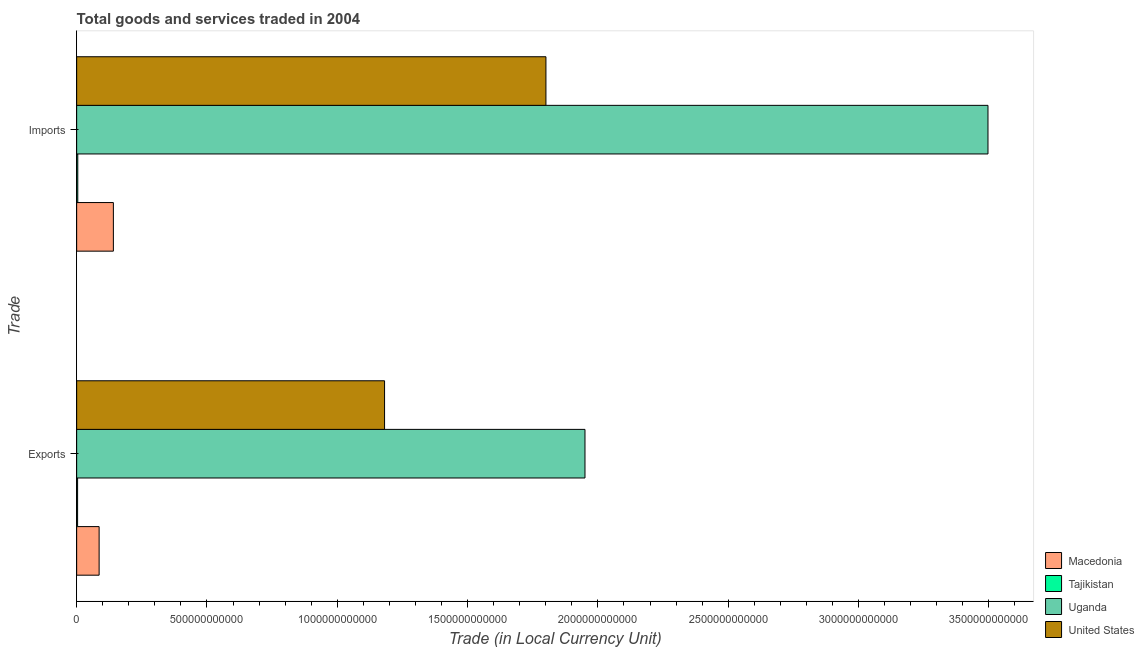How many different coloured bars are there?
Provide a short and direct response. 4. How many groups of bars are there?
Keep it short and to the point. 2. Are the number of bars per tick equal to the number of legend labels?
Provide a short and direct response. Yes. Are the number of bars on each tick of the Y-axis equal?
Provide a succinct answer. Yes. How many bars are there on the 1st tick from the top?
Your answer should be very brief. 4. How many bars are there on the 2nd tick from the bottom?
Give a very brief answer. 4. What is the label of the 2nd group of bars from the top?
Provide a succinct answer. Exports. What is the imports of goods and services in United States?
Offer a very short reply. 1.80e+12. Across all countries, what is the maximum export of goods and services?
Offer a terse response. 1.95e+12. Across all countries, what is the minimum imports of goods and services?
Offer a terse response. 4.31e+09. In which country was the export of goods and services maximum?
Make the answer very short. Uganda. In which country was the imports of goods and services minimum?
Keep it short and to the point. Tajikistan. What is the total imports of goods and services in the graph?
Make the answer very short. 5.44e+12. What is the difference between the imports of goods and services in United States and that in Uganda?
Provide a short and direct response. -1.70e+12. What is the difference between the imports of goods and services in United States and the export of goods and services in Macedonia?
Make the answer very short. 1.71e+12. What is the average export of goods and services per country?
Your response must be concise. 8.05e+11. What is the difference between the imports of goods and services and export of goods and services in Uganda?
Keep it short and to the point. 1.55e+12. In how many countries, is the imports of goods and services greater than 2200000000000 LCU?
Offer a very short reply. 1. What is the ratio of the imports of goods and services in Uganda to that in Tajikistan?
Offer a very short reply. 811.1. In how many countries, is the imports of goods and services greater than the average imports of goods and services taken over all countries?
Give a very brief answer. 2. What does the 4th bar from the top in Exports represents?
Provide a succinct answer. Macedonia. What does the 2nd bar from the bottom in Exports represents?
Give a very brief answer. Tajikistan. What is the difference between two consecutive major ticks on the X-axis?
Offer a very short reply. 5.00e+11. Where does the legend appear in the graph?
Make the answer very short. Bottom right. How are the legend labels stacked?
Provide a succinct answer. Vertical. What is the title of the graph?
Offer a terse response. Total goods and services traded in 2004. What is the label or title of the X-axis?
Give a very brief answer. Trade (in Local Currency Unit). What is the label or title of the Y-axis?
Give a very brief answer. Trade. What is the Trade (in Local Currency Unit) of Macedonia in Exports?
Give a very brief answer. 8.62e+1. What is the Trade (in Local Currency Unit) in Tajikistan in Exports?
Offer a very short reply. 3.60e+09. What is the Trade (in Local Currency Unit) of Uganda in Exports?
Offer a terse response. 1.95e+12. What is the Trade (in Local Currency Unit) in United States in Exports?
Provide a succinct answer. 1.18e+12. What is the Trade (in Local Currency Unit) in Macedonia in Imports?
Provide a succinct answer. 1.41e+11. What is the Trade (in Local Currency Unit) of Tajikistan in Imports?
Offer a very short reply. 4.31e+09. What is the Trade (in Local Currency Unit) in Uganda in Imports?
Your answer should be very brief. 3.50e+12. What is the Trade (in Local Currency Unit) in United States in Imports?
Offer a terse response. 1.80e+12. Across all Trade, what is the maximum Trade (in Local Currency Unit) in Macedonia?
Your response must be concise. 1.41e+11. Across all Trade, what is the maximum Trade (in Local Currency Unit) of Tajikistan?
Your answer should be very brief. 4.31e+09. Across all Trade, what is the maximum Trade (in Local Currency Unit) in Uganda?
Keep it short and to the point. 3.50e+12. Across all Trade, what is the maximum Trade (in Local Currency Unit) of United States?
Provide a short and direct response. 1.80e+12. Across all Trade, what is the minimum Trade (in Local Currency Unit) in Macedonia?
Give a very brief answer. 8.62e+1. Across all Trade, what is the minimum Trade (in Local Currency Unit) of Tajikistan?
Ensure brevity in your answer.  3.60e+09. Across all Trade, what is the minimum Trade (in Local Currency Unit) in Uganda?
Make the answer very short. 1.95e+12. Across all Trade, what is the minimum Trade (in Local Currency Unit) in United States?
Your response must be concise. 1.18e+12. What is the total Trade (in Local Currency Unit) in Macedonia in the graph?
Keep it short and to the point. 2.27e+11. What is the total Trade (in Local Currency Unit) of Tajikistan in the graph?
Provide a short and direct response. 7.91e+09. What is the total Trade (in Local Currency Unit) in Uganda in the graph?
Keep it short and to the point. 5.45e+12. What is the total Trade (in Local Currency Unit) of United States in the graph?
Make the answer very short. 2.98e+12. What is the difference between the Trade (in Local Currency Unit) of Macedonia in Exports and that in Imports?
Provide a short and direct response. -5.46e+1. What is the difference between the Trade (in Local Currency Unit) in Tajikistan in Exports and that in Imports?
Your answer should be compact. -7.15e+08. What is the difference between the Trade (in Local Currency Unit) in Uganda in Exports and that in Imports?
Provide a succinct answer. -1.55e+12. What is the difference between the Trade (in Local Currency Unit) in United States in Exports and that in Imports?
Keep it short and to the point. -6.19e+11. What is the difference between the Trade (in Local Currency Unit) in Macedonia in Exports and the Trade (in Local Currency Unit) in Tajikistan in Imports?
Ensure brevity in your answer.  8.19e+1. What is the difference between the Trade (in Local Currency Unit) of Macedonia in Exports and the Trade (in Local Currency Unit) of Uganda in Imports?
Your answer should be very brief. -3.41e+12. What is the difference between the Trade (in Local Currency Unit) in Macedonia in Exports and the Trade (in Local Currency Unit) in United States in Imports?
Offer a very short reply. -1.71e+12. What is the difference between the Trade (in Local Currency Unit) in Tajikistan in Exports and the Trade (in Local Currency Unit) in Uganda in Imports?
Provide a short and direct response. -3.49e+12. What is the difference between the Trade (in Local Currency Unit) in Tajikistan in Exports and the Trade (in Local Currency Unit) in United States in Imports?
Provide a succinct answer. -1.80e+12. What is the difference between the Trade (in Local Currency Unit) of Uganda in Exports and the Trade (in Local Currency Unit) of United States in Imports?
Keep it short and to the point. 1.50e+11. What is the average Trade (in Local Currency Unit) in Macedonia per Trade?
Your answer should be very brief. 1.14e+11. What is the average Trade (in Local Currency Unit) in Tajikistan per Trade?
Keep it short and to the point. 3.95e+09. What is the average Trade (in Local Currency Unit) in Uganda per Trade?
Your response must be concise. 2.72e+12. What is the average Trade (in Local Currency Unit) of United States per Trade?
Offer a very short reply. 1.49e+12. What is the difference between the Trade (in Local Currency Unit) in Macedonia and Trade (in Local Currency Unit) in Tajikistan in Exports?
Provide a short and direct response. 8.26e+1. What is the difference between the Trade (in Local Currency Unit) of Macedonia and Trade (in Local Currency Unit) of Uganda in Exports?
Your answer should be very brief. -1.86e+12. What is the difference between the Trade (in Local Currency Unit) in Macedonia and Trade (in Local Currency Unit) in United States in Exports?
Offer a very short reply. -1.10e+12. What is the difference between the Trade (in Local Currency Unit) in Tajikistan and Trade (in Local Currency Unit) in Uganda in Exports?
Your answer should be compact. -1.95e+12. What is the difference between the Trade (in Local Currency Unit) in Tajikistan and Trade (in Local Currency Unit) in United States in Exports?
Provide a short and direct response. -1.18e+12. What is the difference between the Trade (in Local Currency Unit) of Uganda and Trade (in Local Currency Unit) of United States in Exports?
Ensure brevity in your answer.  7.69e+11. What is the difference between the Trade (in Local Currency Unit) of Macedonia and Trade (in Local Currency Unit) of Tajikistan in Imports?
Give a very brief answer. 1.37e+11. What is the difference between the Trade (in Local Currency Unit) in Macedonia and Trade (in Local Currency Unit) in Uganda in Imports?
Keep it short and to the point. -3.36e+12. What is the difference between the Trade (in Local Currency Unit) of Macedonia and Trade (in Local Currency Unit) of United States in Imports?
Your response must be concise. -1.66e+12. What is the difference between the Trade (in Local Currency Unit) in Tajikistan and Trade (in Local Currency Unit) in Uganda in Imports?
Offer a very short reply. -3.49e+12. What is the difference between the Trade (in Local Currency Unit) in Tajikistan and Trade (in Local Currency Unit) in United States in Imports?
Your answer should be very brief. -1.80e+12. What is the difference between the Trade (in Local Currency Unit) in Uganda and Trade (in Local Currency Unit) in United States in Imports?
Make the answer very short. 1.70e+12. What is the ratio of the Trade (in Local Currency Unit) in Macedonia in Exports to that in Imports?
Your answer should be very brief. 0.61. What is the ratio of the Trade (in Local Currency Unit) in Tajikistan in Exports to that in Imports?
Make the answer very short. 0.83. What is the ratio of the Trade (in Local Currency Unit) of Uganda in Exports to that in Imports?
Your response must be concise. 0.56. What is the ratio of the Trade (in Local Currency Unit) of United States in Exports to that in Imports?
Ensure brevity in your answer.  0.66. What is the difference between the highest and the second highest Trade (in Local Currency Unit) in Macedonia?
Give a very brief answer. 5.46e+1. What is the difference between the highest and the second highest Trade (in Local Currency Unit) of Tajikistan?
Offer a terse response. 7.15e+08. What is the difference between the highest and the second highest Trade (in Local Currency Unit) of Uganda?
Your response must be concise. 1.55e+12. What is the difference between the highest and the second highest Trade (in Local Currency Unit) in United States?
Provide a succinct answer. 6.19e+11. What is the difference between the highest and the lowest Trade (in Local Currency Unit) in Macedonia?
Give a very brief answer. 5.46e+1. What is the difference between the highest and the lowest Trade (in Local Currency Unit) in Tajikistan?
Your answer should be very brief. 7.15e+08. What is the difference between the highest and the lowest Trade (in Local Currency Unit) of Uganda?
Your answer should be compact. 1.55e+12. What is the difference between the highest and the lowest Trade (in Local Currency Unit) in United States?
Offer a very short reply. 6.19e+11. 